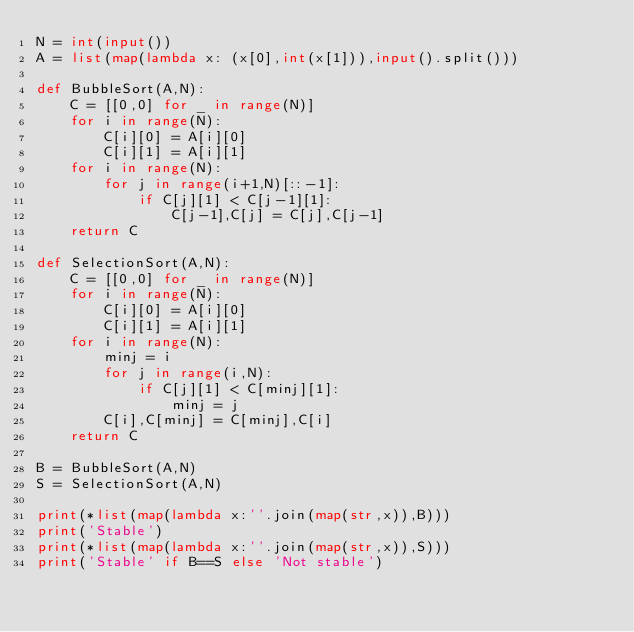Convert code to text. <code><loc_0><loc_0><loc_500><loc_500><_Python_>N = int(input())
A = list(map(lambda x: (x[0],int(x[1])),input().split()))

def BubbleSort(A,N):
    C = [[0,0] for _ in range(N)]
    for i in range(N):
        C[i][0] = A[i][0]
        C[i][1] = A[i][1]
    for i in range(N):
        for j in range(i+1,N)[::-1]:
            if C[j][1] < C[j-1][1]:
                C[j-1],C[j] = C[j],C[j-1]
    return C

def SelectionSort(A,N):
    C = [[0,0] for _ in range(N)]
    for i in range(N):
        C[i][0] = A[i][0]
        C[i][1] = A[i][1]
    for i in range(N):
        minj = i
        for j in range(i,N):
            if C[j][1] < C[minj][1]:
                minj = j
        C[i],C[minj] = C[minj],C[i]
    return C

B = BubbleSort(A,N)
S = SelectionSort(A,N)

print(*list(map(lambda x:''.join(map(str,x)),B)))
print('Stable')
print(*list(map(lambda x:''.join(map(str,x)),S)))
print('Stable' if B==S else 'Not stable')
</code> 